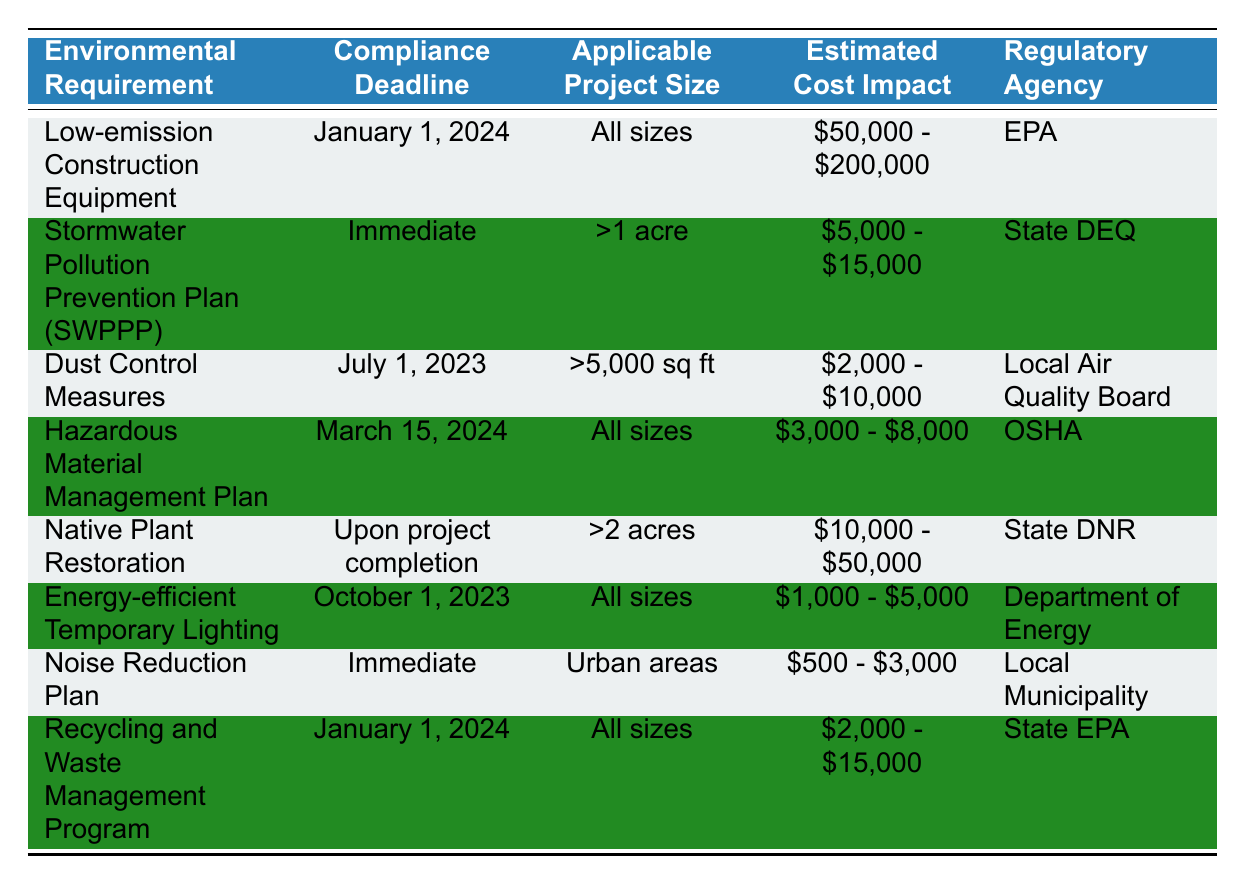What is the compliance deadline for Low-emission Construction Equipment? The table shows that the compliance deadline for Low-emission Construction Equipment is January 1, 2024.
Answer: January 1, 2024 Which regulatory agency is responsible for the Stormwater Pollution Prevention Plan (SWPPP)? According to the table, the regulatory agency for the Stormwater Pollution Prevention Plan (SWPPP) is the State DEQ.
Answer: State DEQ How much is the estimated cost impact for the Noise Reduction Plan? The table indicates that the estimated cost impact for the Noise Reduction Plan ranges from $500 to $3,000.
Answer: $500 - $3,000 Are all construction sites required to implement Dust Control Measures? The table states that Dust Control Measures are applicable to construction sites greater than 5,000 square feet, which means not all sites are required to implement them.
Answer: No What is the average estimated cost impact for environmental requirements applicable to all sizes of projects? The applicable projects are Low-emission Construction Equipment ($50,000 - $200,000), Hazardous Material Management Plan ($3,000 - $8,000), Energy-efficient Temporary Lighting ($1,000 - $5,000), and Recycling and Waste Management Program ($2,000 - $15,000). The average can be calculated as follows: (125000 + 5000 + 3000 + 8500) / 4 = 34,625 (using midpoints for ranges).
Answer: $34,625 Which environmental requirement has the earliest compliance deadline? By examining the compliance deadlines, Dust Control Measures, and the Noise Reduction Plan both have immediate compliance deadlines, which are earlier than the other requirements.
Answer: Immediate Is the Native Plant Restoration requirement associated with projects of all sizes? The table specifies that Native Plant Restoration only applies to projects exceeding 2 acres, indicating that it does not apply to all sizes.
Answer: No What are the cost implications for a project requiring a Stormwater Pollution Prevention Plan? The cost implications for a Stormwater Pollution Prevention Plan range from $5,000 to $15,000, as per the table.
Answer: $5,000 - $15,000 How many environmental requirements have a compliance deadline of January 1, 2024? By reviewing the table, there are two environmental requirements with a compliance deadline of January 1, 2024: Low-emission Construction Equipment and Recycling and Waste Management Program.
Answer: 2 What is the cost range for Energy-efficient Temporary Lighting? The cost range for Energy-efficient Temporary Lighting is $1,000 to $5,000 according to the table.
Answer: $1,000 - $5,000 Which environmental requirement is related to urban areas? The table indicates that the Noise Reduction Plan is specifically associated with urban areas.
Answer: Noise Reduction Plan 